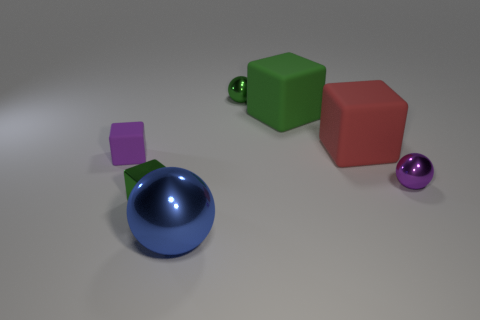Is the color of the tiny metal cube the same as the tiny ball behind the tiny purple matte block?
Keep it short and to the point. Yes. Are there more green things behind the small green block than metallic blocks?
Your answer should be compact. Yes. What number of purple metal balls are behind the small sphere behind the tiny sphere that is in front of the red thing?
Ensure brevity in your answer.  0. There is a tiny green object that is left of the large blue metallic object; is its shape the same as the large blue object?
Make the answer very short. No. There is a purple object that is to the left of the blue object; what material is it?
Your answer should be compact. Rubber. There is a shiny object that is on the left side of the green ball and behind the blue sphere; what shape is it?
Provide a succinct answer. Cube. What is the material of the tiny purple cube?
Your response must be concise. Rubber. How many balls are large red objects or small metallic things?
Give a very brief answer. 2. Does the tiny purple sphere have the same material as the purple block?
Provide a short and direct response. No. There is a red object that is the same shape as the purple matte object; what is its size?
Ensure brevity in your answer.  Large. 